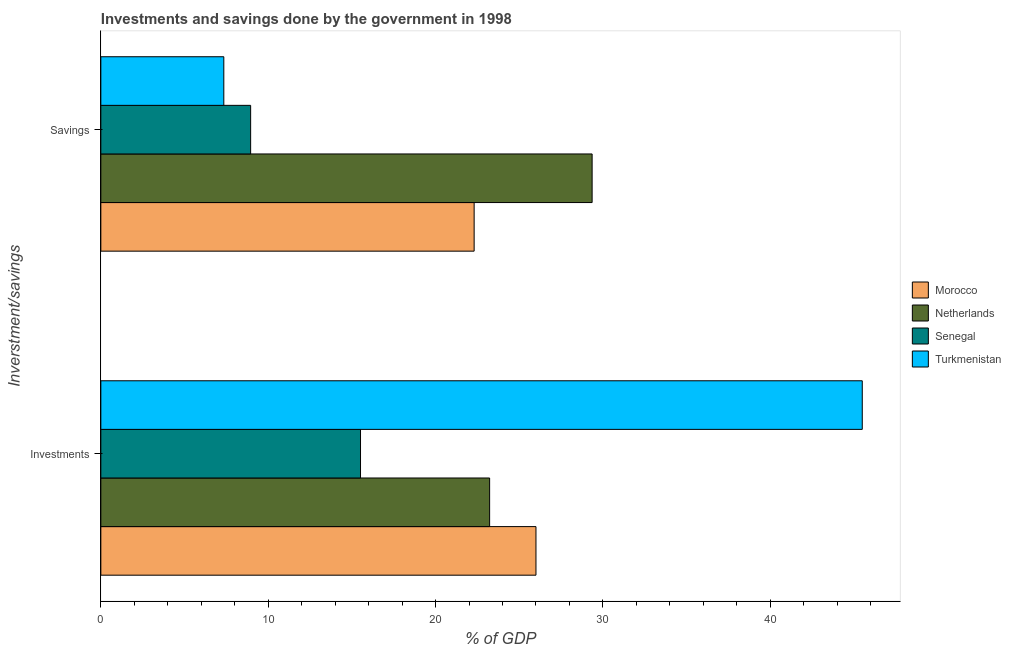How many groups of bars are there?
Your response must be concise. 2. Are the number of bars per tick equal to the number of legend labels?
Your response must be concise. Yes. What is the label of the 2nd group of bars from the top?
Offer a terse response. Investments. What is the savings of government in Morocco?
Provide a short and direct response. 22.3. Across all countries, what is the maximum investments of government?
Keep it short and to the point. 45.49. Across all countries, what is the minimum savings of government?
Offer a very short reply. 7.35. In which country was the investments of government maximum?
Keep it short and to the point. Turkmenistan. In which country was the investments of government minimum?
Keep it short and to the point. Senegal. What is the total investments of government in the graph?
Your response must be concise. 110.24. What is the difference between the savings of government in Morocco and that in Senegal?
Provide a short and direct response. 13.35. What is the difference between the savings of government in Netherlands and the investments of government in Senegal?
Offer a terse response. 13.84. What is the average investments of government per country?
Give a very brief answer. 27.56. What is the difference between the investments of government and savings of government in Netherlands?
Keep it short and to the point. -6.12. In how many countries, is the investments of government greater than 4 %?
Ensure brevity in your answer.  4. What is the ratio of the investments of government in Turkmenistan to that in Senegal?
Keep it short and to the point. 2.93. Is the savings of government in Morocco less than that in Senegal?
Your answer should be compact. No. In how many countries, is the savings of government greater than the average savings of government taken over all countries?
Provide a succinct answer. 2. What does the 4th bar from the top in Savings represents?
Ensure brevity in your answer.  Morocco. What does the 1st bar from the bottom in Investments represents?
Your answer should be very brief. Morocco. Are all the bars in the graph horizontal?
Give a very brief answer. Yes. How many countries are there in the graph?
Offer a very short reply. 4. What is the difference between two consecutive major ticks on the X-axis?
Make the answer very short. 10. How many legend labels are there?
Provide a succinct answer. 4. How are the legend labels stacked?
Offer a terse response. Vertical. What is the title of the graph?
Give a very brief answer. Investments and savings done by the government in 1998. What is the label or title of the X-axis?
Offer a terse response. % of GDP. What is the label or title of the Y-axis?
Give a very brief answer. Inverstment/savings. What is the % of GDP in Morocco in Investments?
Give a very brief answer. 26. What is the % of GDP of Netherlands in Investments?
Provide a short and direct response. 23.23. What is the % of GDP of Senegal in Investments?
Ensure brevity in your answer.  15.52. What is the % of GDP in Turkmenistan in Investments?
Make the answer very short. 45.49. What is the % of GDP in Morocco in Savings?
Provide a short and direct response. 22.3. What is the % of GDP in Netherlands in Savings?
Your response must be concise. 29.35. What is the % of GDP in Senegal in Savings?
Keep it short and to the point. 8.95. What is the % of GDP in Turkmenistan in Savings?
Give a very brief answer. 7.35. Across all Inverstment/savings, what is the maximum % of GDP in Morocco?
Ensure brevity in your answer.  26. Across all Inverstment/savings, what is the maximum % of GDP in Netherlands?
Offer a terse response. 29.35. Across all Inverstment/savings, what is the maximum % of GDP of Senegal?
Offer a very short reply. 15.52. Across all Inverstment/savings, what is the maximum % of GDP in Turkmenistan?
Keep it short and to the point. 45.49. Across all Inverstment/savings, what is the minimum % of GDP in Morocco?
Make the answer very short. 22.3. Across all Inverstment/savings, what is the minimum % of GDP of Netherlands?
Offer a very short reply. 23.23. Across all Inverstment/savings, what is the minimum % of GDP of Senegal?
Ensure brevity in your answer.  8.95. Across all Inverstment/savings, what is the minimum % of GDP in Turkmenistan?
Give a very brief answer. 7.35. What is the total % of GDP of Morocco in the graph?
Offer a very short reply. 48.3. What is the total % of GDP in Netherlands in the graph?
Provide a short and direct response. 52.58. What is the total % of GDP in Senegal in the graph?
Your answer should be very brief. 24.47. What is the total % of GDP of Turkmenistan in the graph?
Make the answer very short. 52.84. What is the difference between the % of GDP in Morocco in Investments and that in Savings?
Give a very brief answer. 3.69. What is the difference between the % of GDP in Netherlands in Investments and that in Savings?
Give a very brief answer. -6.12. What is the difference between the % of GDP of Senegal in Investments and that in Savings?
Keep it short and to the point. 6.57. What is the difference between the % of GDP in Turkmenistan in Investments and that in Savings?
Your answer should be compact. 38.15. What is the difference between the % of GDP in Morocco in Investments and the % of GDP in Netherlands in Savings?
Keep it short and to the point. -3.36. What is the difference between the % of GDP in Morocco in Investments and the % of GDP in Senegal in Savings?
Make the answer very short. 17.05. What is the difference between the % of GDP of Morocco in Investments and the % of GDP of Turkmenistan in Savings?
Keep it short and to the point. 18.65. What is the difference between the % of GDP in Netherlands in Investments and the % of GDP in Senegal in Savings?
Your answer should be very brief. 14.28. What is the difference between the % of GDP in Netherlands in Investments and the % of GDP in Turkmenistan in Savings?
Offer a very short reply. 15.88. What is the difference between the % of GDP in Senegal in Investments and the % of GDP in Turkmenistan in Savings?
Ensure brevity in your answer.  8.17. What is the average % of GDP in Morocco per Inverstment/savings?
Your answer should be compact. 24.15. What is the average % of GDP of Netherlands per Inverstment/savings?
Your answer should be compact. 26.29. What is the average % of GDP of Senegal per Inverstment/savings?
Keep it short and to the point. 12.23. What is the average % of GDP in Turkmenistan per Inverstment/savings?
Provide a succinct answer. 26.42. What is the difference between the % of GDP in Morocco and % of GDP in Netherlands in Investments?
Your answer should be very brief. 2.77. What is the difference between the % of GDP in Morocco and % of GDP in Senegal in Investments?
Offer a very short reply. 10.48. What is the difference between the % of GDP of Morocco and % of GDP of Turkmenistan in Investments?
Your response must be concise. -19.5. What is the difference between the % of GDP of Netherlands and % of GDP of Senegal in Investments?
Your response must be concise. 7.71. What is the difference between the % of GDP in Netherlands and % of GDP in Turkmenistan in Investments?
Give a very brief answer. -22.27. What is the difference between the % of GDP of Senegal and % of GDP of Turkmenistan in Investments?
Provide a succinct answer. -29.98. What is the difference between the % of GDP of Morocco and % of GDP of Netherlands in Savings?
Your answer should be compact. -7.05. What is the difference between the % of GDP of Morocco and % of GDP of Senegal in Savings?
Your response must be concise. 13.35. What is the difference between the % of GDP in Morocco and % of GDP in Turkmenistan in Savings?
Your answer should be compact. 14.96. What is the difference between the % of GDP of Netherlands and % of GDP of Senegal in Savings?
Offer a terse response. 20.4. What is the difference between the % of GDP in Netherlands and % of GDP in Turkmenistan in Savings?
Your answer should be compact. 22.01. What is the difference between the % of GDP in Senegal and % of GDP in Turkmenistan in Savings?
Give a very brief answer. 1.6. What is the ratio of the % of GDP in Morocco in Investments to that in Savings?
Provide a succinct answer. 1.17. What is the ratio of the % of GDP of Netherlands in Investments to that in Savings?
Provide a short and direct response. 0.79. What is the ratio of the % of GDP of Senegal in Investments to that in Savings?
Your response must be concise. 1.73. What is the ratio of the % of GDP in Turkmenistan in Investments to that in Savings?
Provide a short and direct response. 6.19. What is the difference between the highest and the second highest % of GDP of Morocco?
Provide a succinct answer. 3.69. What is the difference between the highest and the second highest % of GDP of Netherlands?
Ensure brevity in your answer.  6.12. What is the difference between the highest and the second highest % of GDP in Senegal?
Give a very brief answer. 6.57. What is the difference between the highest and the second highest % of GDP in Turkmenistan?
Provide a succinct answer. 38.15. What is the difference between the highest and the lowest % of GDP in Morocco?
Give a very brief answer. 3.69. What is the difference between the highest and the lowest % of GDP in Netherlands?
Your response must be concise. 6.12. What is the difference between the highest and the lowest % of GDP of Senegal?
Keep it short and to the point. 6.57. What is the difference between the highest and the lowest % of GDP in Turkmenistan?
Your answer should be very brief. 38.15. 